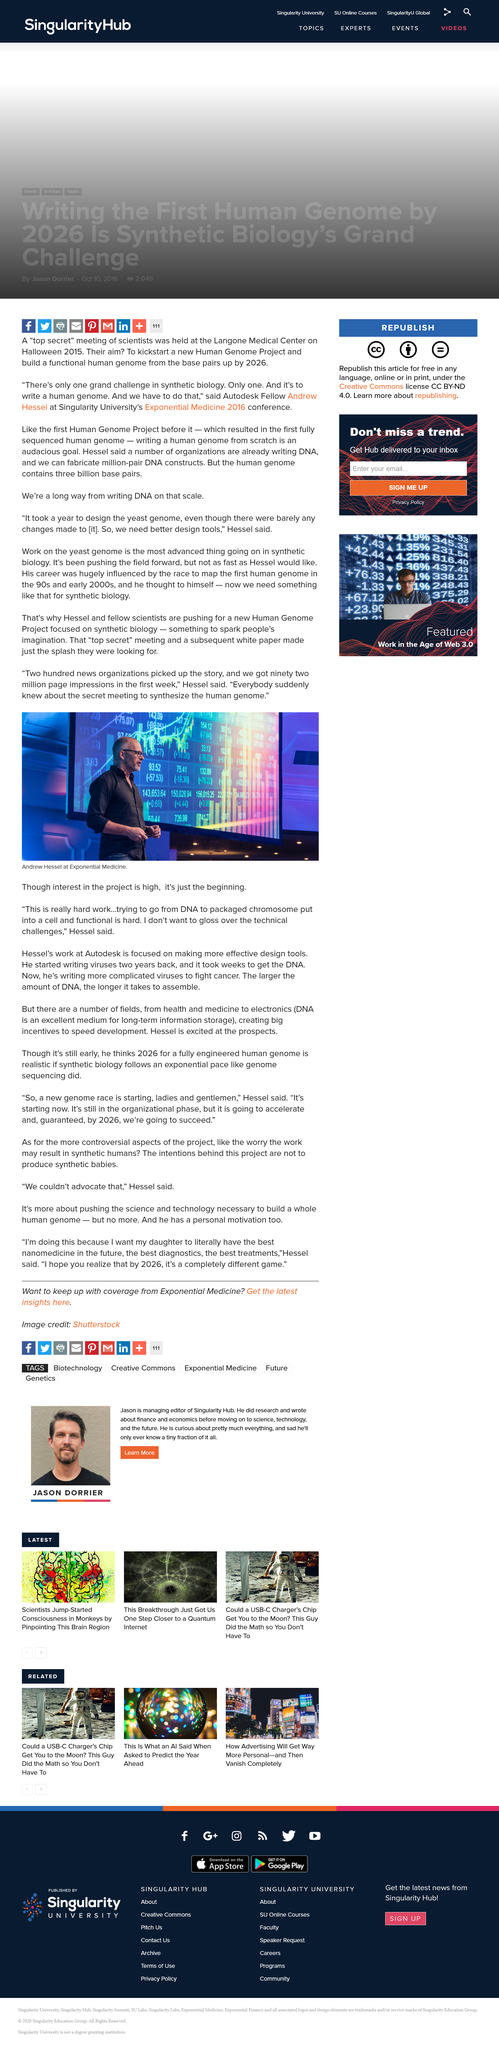Outline some significant characteristics in this image. Andrew Hessel is depicted in the photograph. Andrew Hessel does not want to gloss over the technical challenges. Andrew Hessel did say, "This is really hard work? 